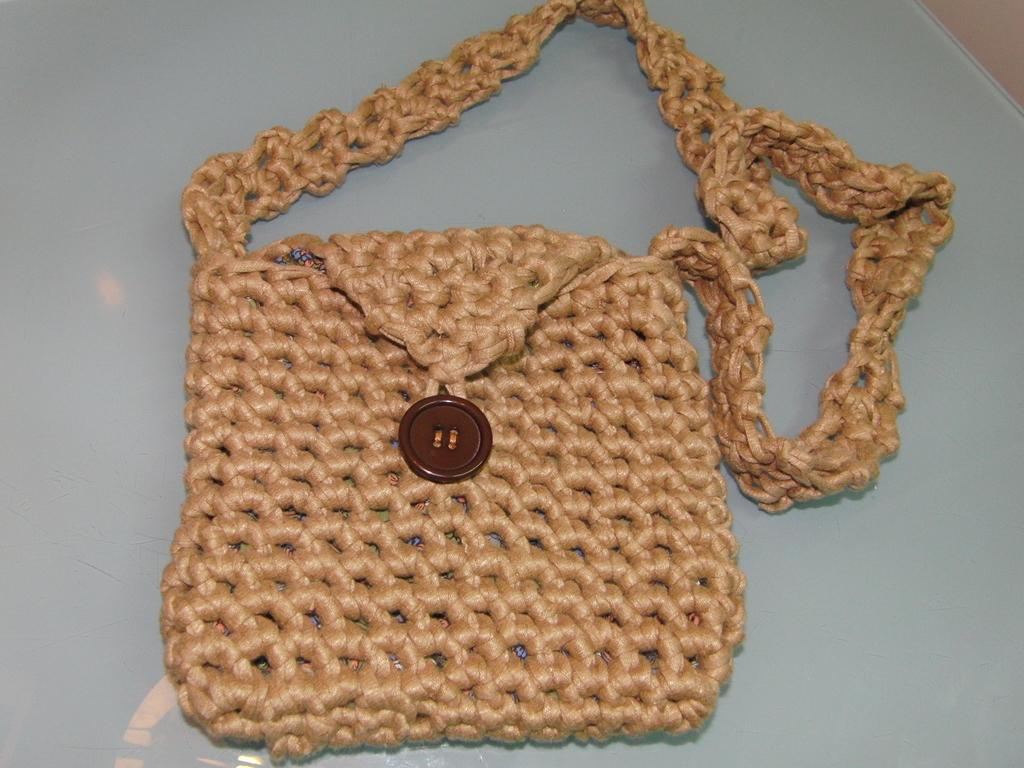What is the color of the main object in the image? The main object in the image is cream-colored. What feature can be seen on the object? The object has a brown-colored button. What type of food is being prepared in the image? There is no food or cooking activity present in the image. What language is being spoken in the image? There is no indication of any spoken language in the image. 